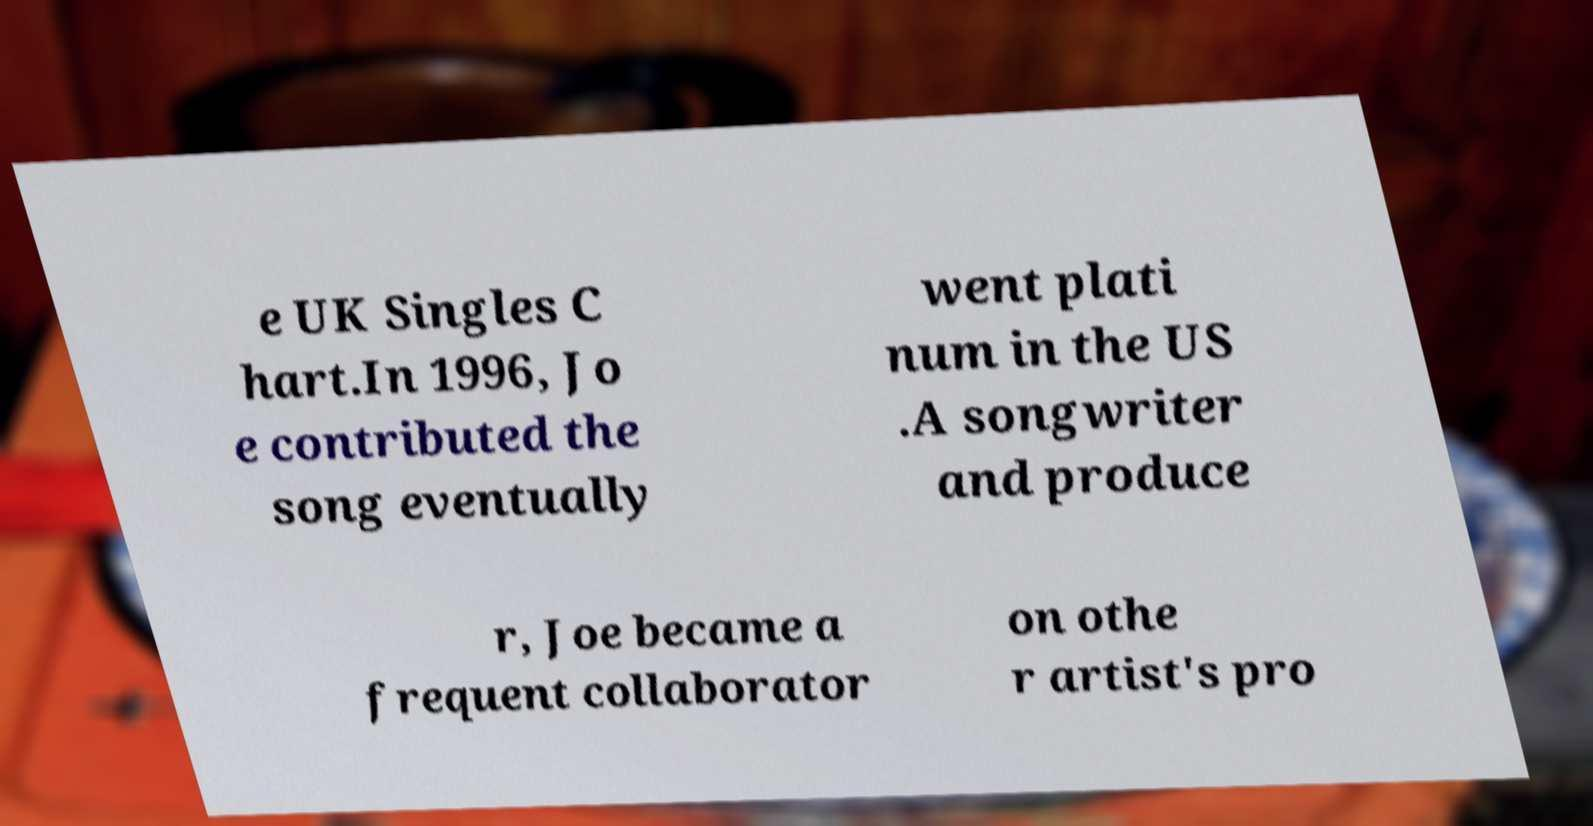Could you assist in decoding the text presented in this image and type it out clearly? e UK Singles C hart.In 1996, Jo e contributed the song eventually went plati num in the US .A songwriter and produce r, Joe became a frequent collaborator on othe r artist's pro 